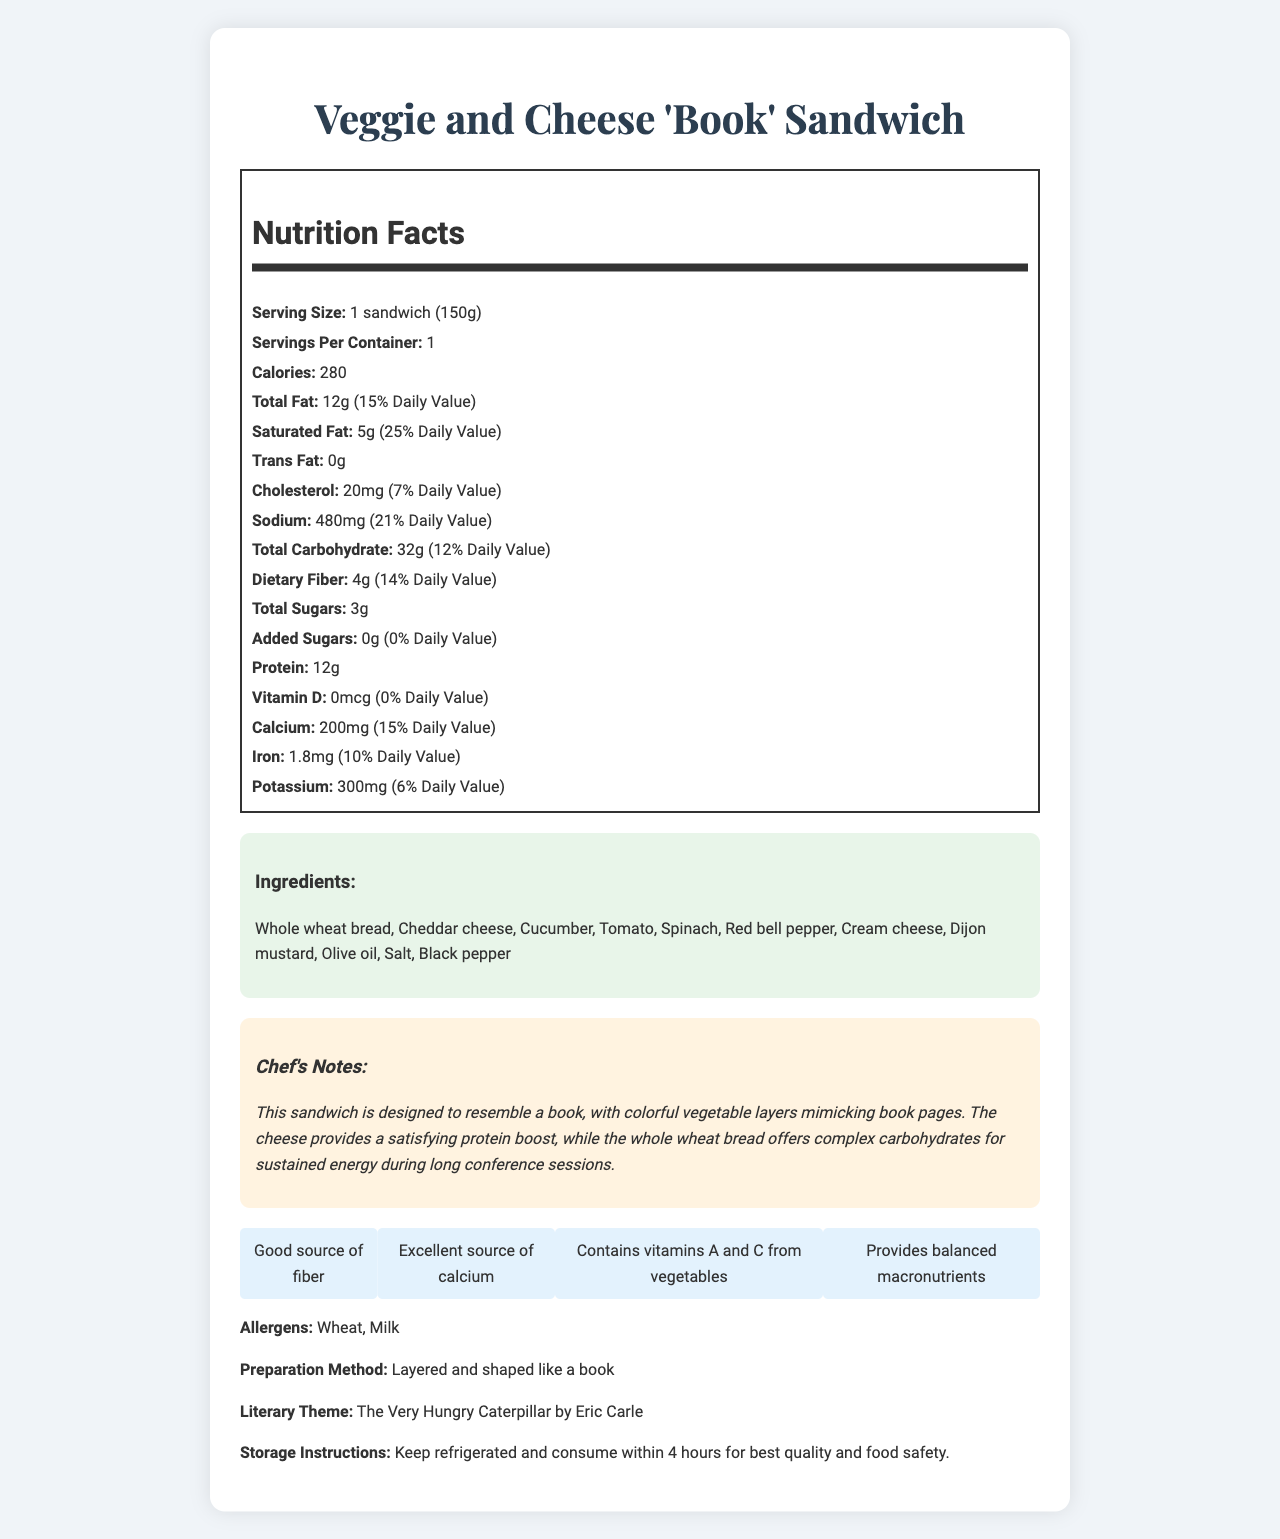what is the serving size? The serving size is indicated as "1 sandwich (150g)" in the nutrition facts section.
Answer: 1 sandwich (150g) how many calories are in one serving? The calories are listed as 280 per serving in the nutrition facts section.
Answer: 280 what is the total fat content per serving? The total fat content is listed as 12g in the nutrition facts section.
Answer: 12g what percentage of the Daily Value (DV) does the saturated fat provide? The percentage of the Daily Value for saturated fat is listed as 25% in the nutrition facts section.
Answer: 25% does the sandwich contain any trans fat? The trans fat content is listed as 0g in the nutrition facts section.
Answer: No A person following a diet of 2,000 calories should limit total fat to 78g per day. How much total fat does one serving of this sandwich contribute to this limit? A. 6% B. 12% C. 15% D. 25% The total fat in one serving is 12g, which contributes 15% of the Daily Value for a 2,000 calorie diet.
Answer: C. 15% what are the main ingredients in the Veggie and Cheese 'Book' Sandwich? The ingredients are listed in the ingredients section.
Answer: Whole wheat bread, Cheddar cheese, Cucumber, Tomato, Spinach, Red bell pepper, Cream cheese, Dijon mustard, Olive oil, Salt, Black pepper How much dietary fiber does one sandwich provide? The dietary fiber content is listed as 4g per sandwich in the nutrition facts section.
Answer: 4g what allergens are present in this sandwich? The allergens are listed as "Wheat, Milk" in the allergens section.
Answer: Wheat, Milk what preparation method is used to make this sandwich? The preparation method is described as "Layered and shaped like a book" in the document.
Answer: Layered and shaped like a book is this sandwich a good source of fiber? One of the nutritional highlights mentions that the sandwich is a good source of fiber.
Answer: Yes which vitamin is *not* present in significant amounts in the sandwich? A. Vitamin A B. Vitamin C C. Vitamin D D. Calcium The vitamin D content is listed as 0mcg and 0% Daily Value, so it is not present in significant amounts.
Answer: C. Vitamin D does the sandwich's theme relate to a literary work? The literary theme is mentioned as "The Very Hungry Caterpillar by Eric Carle."
Answer: Yes how should this sandwich be stored for best quality and safety? The storage instructions specify to keep the sandwich refrigerated and consume within 4 hours.
Answer: Keep refrigerated and consume within 4 hours what are the calorie, fat, carbohydrate, and protein contents per serving of this sandwich? The nutrition facts section provides these values for calories, total fat, carbohydrates, and protein.
Answer: 280 calories, 12g fat, 32g carbohydrate, 12g protein summarize the main idea of the document. The document serves as a comprehensive guide for understanding the nutritional aspects, ingredients, preparation, and thematic presentation of the Veggie and Cheese 'Book' Sandwich.
Answer: This document provides the nutritional facts, ingredients, allergens, preparation method, and related literary theme for the Veggie and Cheese 'Book' Sandwich. It details the nutritional content per serving, highlights the benefits such as being a good source of fiber and calcium, and offers storage instructions. The sandwich is designed to resemble a book to fit the theme of "The Very Hungry Caterpillar" by Eric Carle, offering balanced nutrition for a teacher's themed event. what is the daily value percentage of potassium provided by this sandwich? The daily value percentage for potassium is 6% as listed in the nutrition facts section.
Answer: 6% how much-added sugar is in the sandwich? The added sugars are listed as 0g in the nutrition facts section.
Answer: 0g is this sandwich suitable for someone with a gluten intolerance? The ingredients list includes whole wheat bread, which contains gluten, making the sandwich unsuitable for someone with a gluten intolerance.
Answer: No how many servings are in the container? The servings per container are listed as 1 in the nutrition facts section.
Answer: 1 what are some of the nutritional highlights of this sandwich? The document lists these highlights in the nutritional highlights section.
Answer: Good source of fiber, excellent source of calcium, contains vitamins A and C from vegetables, provides balanced macronutrients where can I find more details about the preparation method for this sandwich? The document only provides the method as "Layered and shaped like a book," without further details.
Answer: Not enough information 